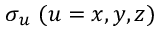<formula> <loc_0><loc_0><loc_500><loc_500>\sigma _ { u } ( u = x , y , z )</formula> 